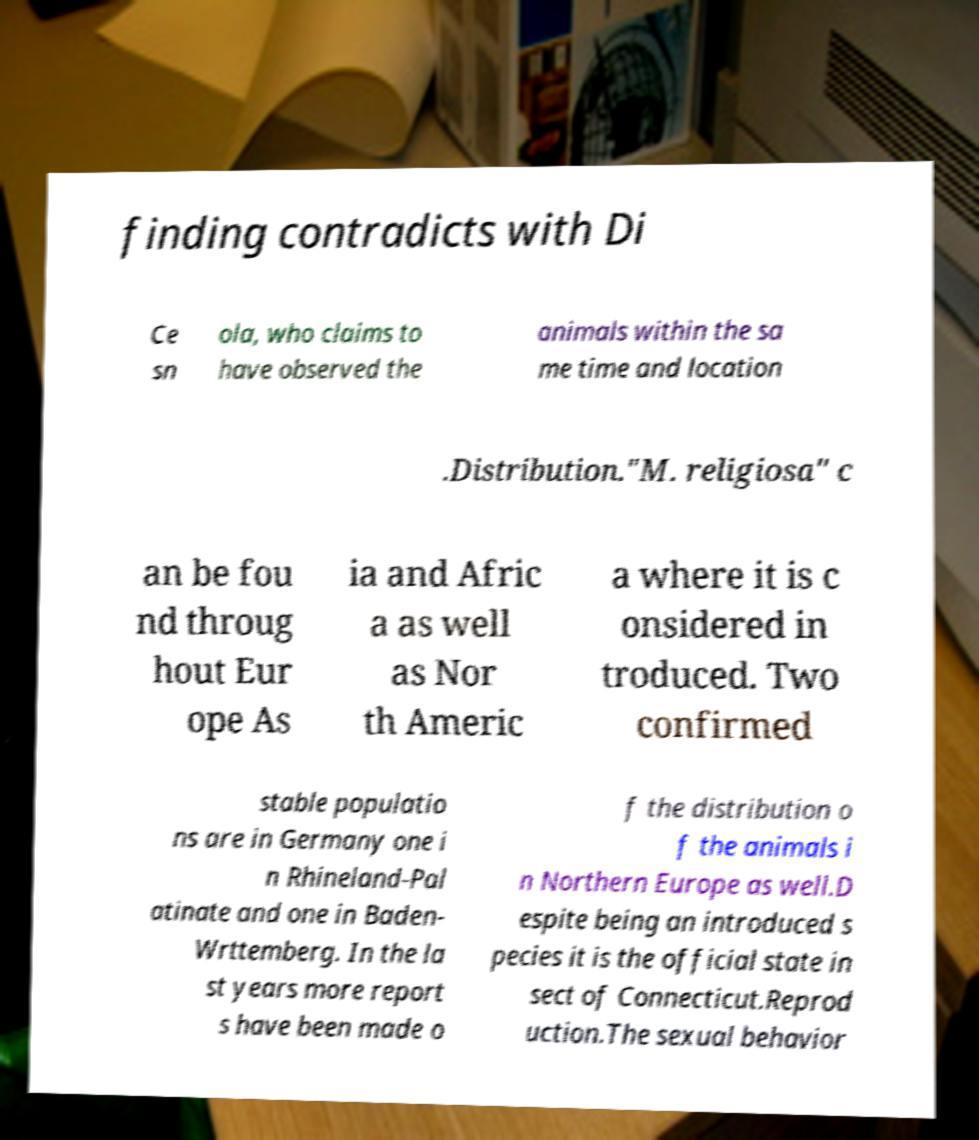I need the written content from this picture converted into text. Can you do that? finding contradicts with Di Ce sn ola, who claims to have observed the animals within the sa me time and location .Distribution."M. religiosa" c an be fou nd throug hout Eur ope As ia and Afric a as well as Nor th Americ a where it is c onsidered in troduced. Two confirmed stable populatio ns are in Germany one i n Rhineland-Pal atinate and one in Baden- Wrttemberg. In the la st years more report s have been made o f the distribution o f the animals i n Northern Europe as well.D espite being an introduced s pecies it is the official state in sect of Connecticut.Reprod uction.The sexual behavior 